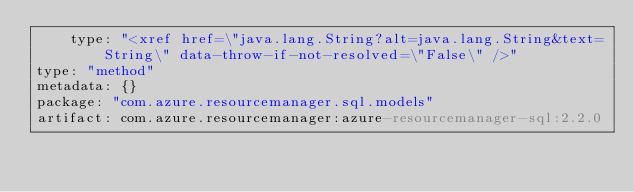Convert code to text. <code><loc_0><loc_0><loc_500><loc_500><_YAML_>    type: "<xref href=\"java.lang.String?alt=java.lang.String&text=String\" data-throw-if-not-resolved=\"False\" />"
type: "method"
metadata: {}
package: "com.azure.resourcemanager.sql.models"
artifact: com.azure.resourcemanager:azure-resourcemanager-sql:2.2.0
</code> 